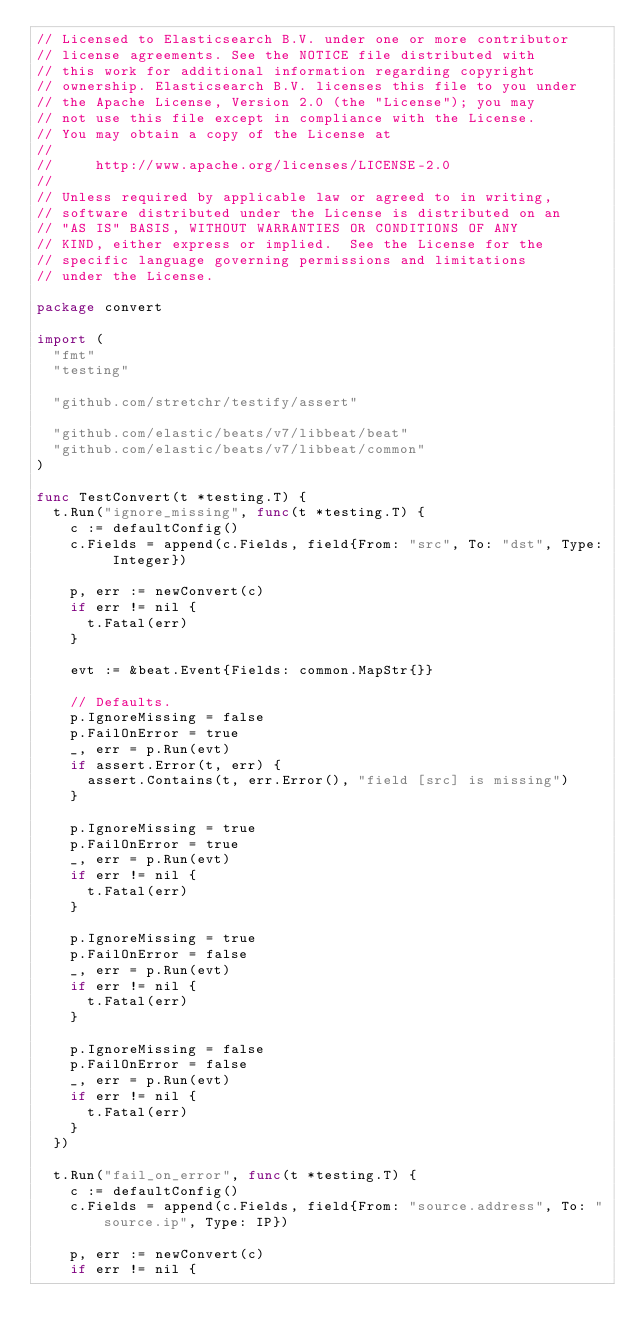<code> <loc_0><loc_0><loc_500><loc_500><_Go_>// Licensed to Elasticsearch B.V. under one or more contributor
// license agreements. See the NOTICE file distributed with
// this work for additional information regarding copyright
// ownership. Elasticsearch B.V. licenses this file to you under
// the Apache License, Version 2.0 (the "License"); you may
// not use this file except in compliance with the License.
// You may obtain a copy of the License at
//
//     http://www.apache.org/licenses/LICENSE-2.0
//
// Unless required by applicable law or agreed to in writing,
// software distributed under the License is distributed on an
// "AS IS" BASIS, WITHOUT WARRANTIES OR CONDITIONS OF ANY
// KIND, either express or implied.  See the License for the
// specific language governing permissions and limitations
// under the License.

package convert

import (
	"fmt"
	"testing"

	"github.com/stretchr/testify/assert"

	"github.com/elastic/beats/v7/libbeat/beat"
	"github.com/elastic/beats/v7/libbeat/common"
)

func TestConvert(t *testing.T) {
	t.Run("ignore_missing", func(t *testing.T) {
		c := defaultConfig()
		c.Fields = append(c.Fields, field{From: "src", To: "dst", Type: Integer})

		p, err := newConvert(c)
		if err != nil {
			t.Fatal(err)
		}

		evt := &beat.Event{Fields: common.MapStr{}}

		// Defaults.
		p.IgnoreMissing = false
		p.FailOnError = true
		_, err = p.Run(evt)
		if assert.Error(t, err) {
			assert.Contains(t, err.Error(), "field [src] is missing")
		}

		p.IgnoreMissing = true
		p.FailOnError = true
		_, err = p.Run(evt)
		if err != nil {
			t.Fatal(err)
		}

		p.IgnoreMissing = true
		p.FailOnError = false
		_, err = p.Run(evt)
		if err != nil {
			t.Fatal(err)
		}

		p.IgnoreMissing = false
		p.FailOnError = false
		_, err = p.Run(evt)
		if err != nil {
			t.Fatal(err)
		}
	})

	t.Run("fail_on_error", func(t *testing.T) {
		c := defaultConfig()
		c.Fields = append(c.Fields, field{From: "source.address", To: "source.ip", Type: IP})

		p, err := newConvert(c)
		if err != nil {</code> 